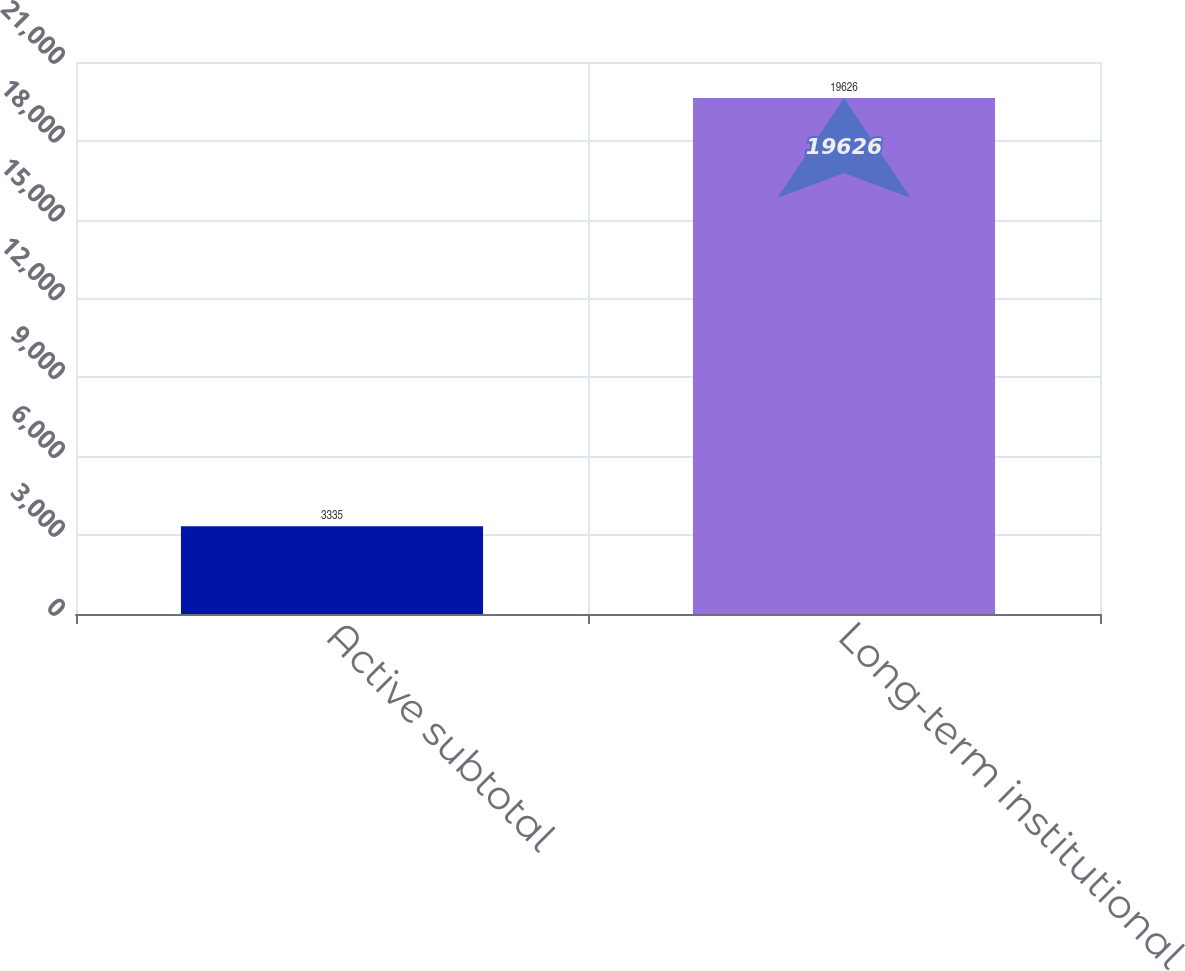Convert chart to OTSL. <chart><loc_0><loc_0><loc_500><loc_500><bar_chart><fcel>Active subtotal<fcel>Long-term institutional<nl><fcel>3335<fcel>19626<nl></chart> 